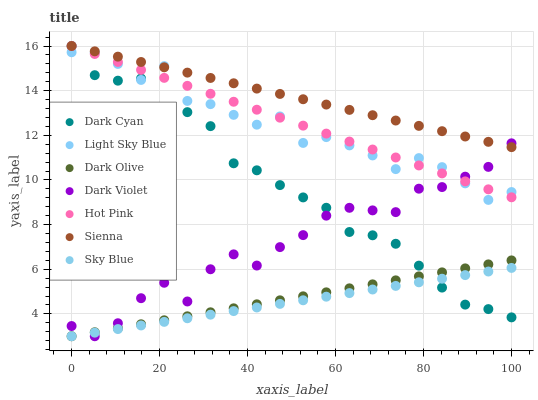Does Sky Blue have the minimum area under the curve?
Answer yes or no. Yes. Does Sienna have the maximum area under the curve?
Answer yes or no. Yes. Does Dark Olive have the minimum area under the curve?
Answer yes or no. No. Does Dark Olive have the maximum area under the curve?
Answer yes or no. No. Is Sky Blue the smoothest?
Answer yes or no. Yes. Is Light Sky Blue the roughest?
Answer yes or no. Yes. Is Dark Olive the smoothest?
Answer yes or no. No. Is Dark Olive the roughest?
Answer yes or no. No. Does Dark Olive have the lowest value?
Answer yes or no. Yes. Does Sienna have the lowest value?
Answer yes or no. No. Does Dark Cyan have the highest value?
Answer yes or no. Yes. Does Dark Olive have the highest value?
Answer yes or no. No. Is Dark Olive less than Hot Pink?
Answer yes or no. Yes. Is Hot Pink greater than Sky Blue?
Answer yes or no. Yes. Does Sky Blue intersect Dark Cyan?
Answer yes or no. Yes. Is Sky Blue less than Dark Cyan?
Answer yes or no. No. Is Sky Blue greater than Dark Cyan?
Answer yes or no. No. Does Dark Olive intersect Hot Pink?
Answer yes or no. No. 